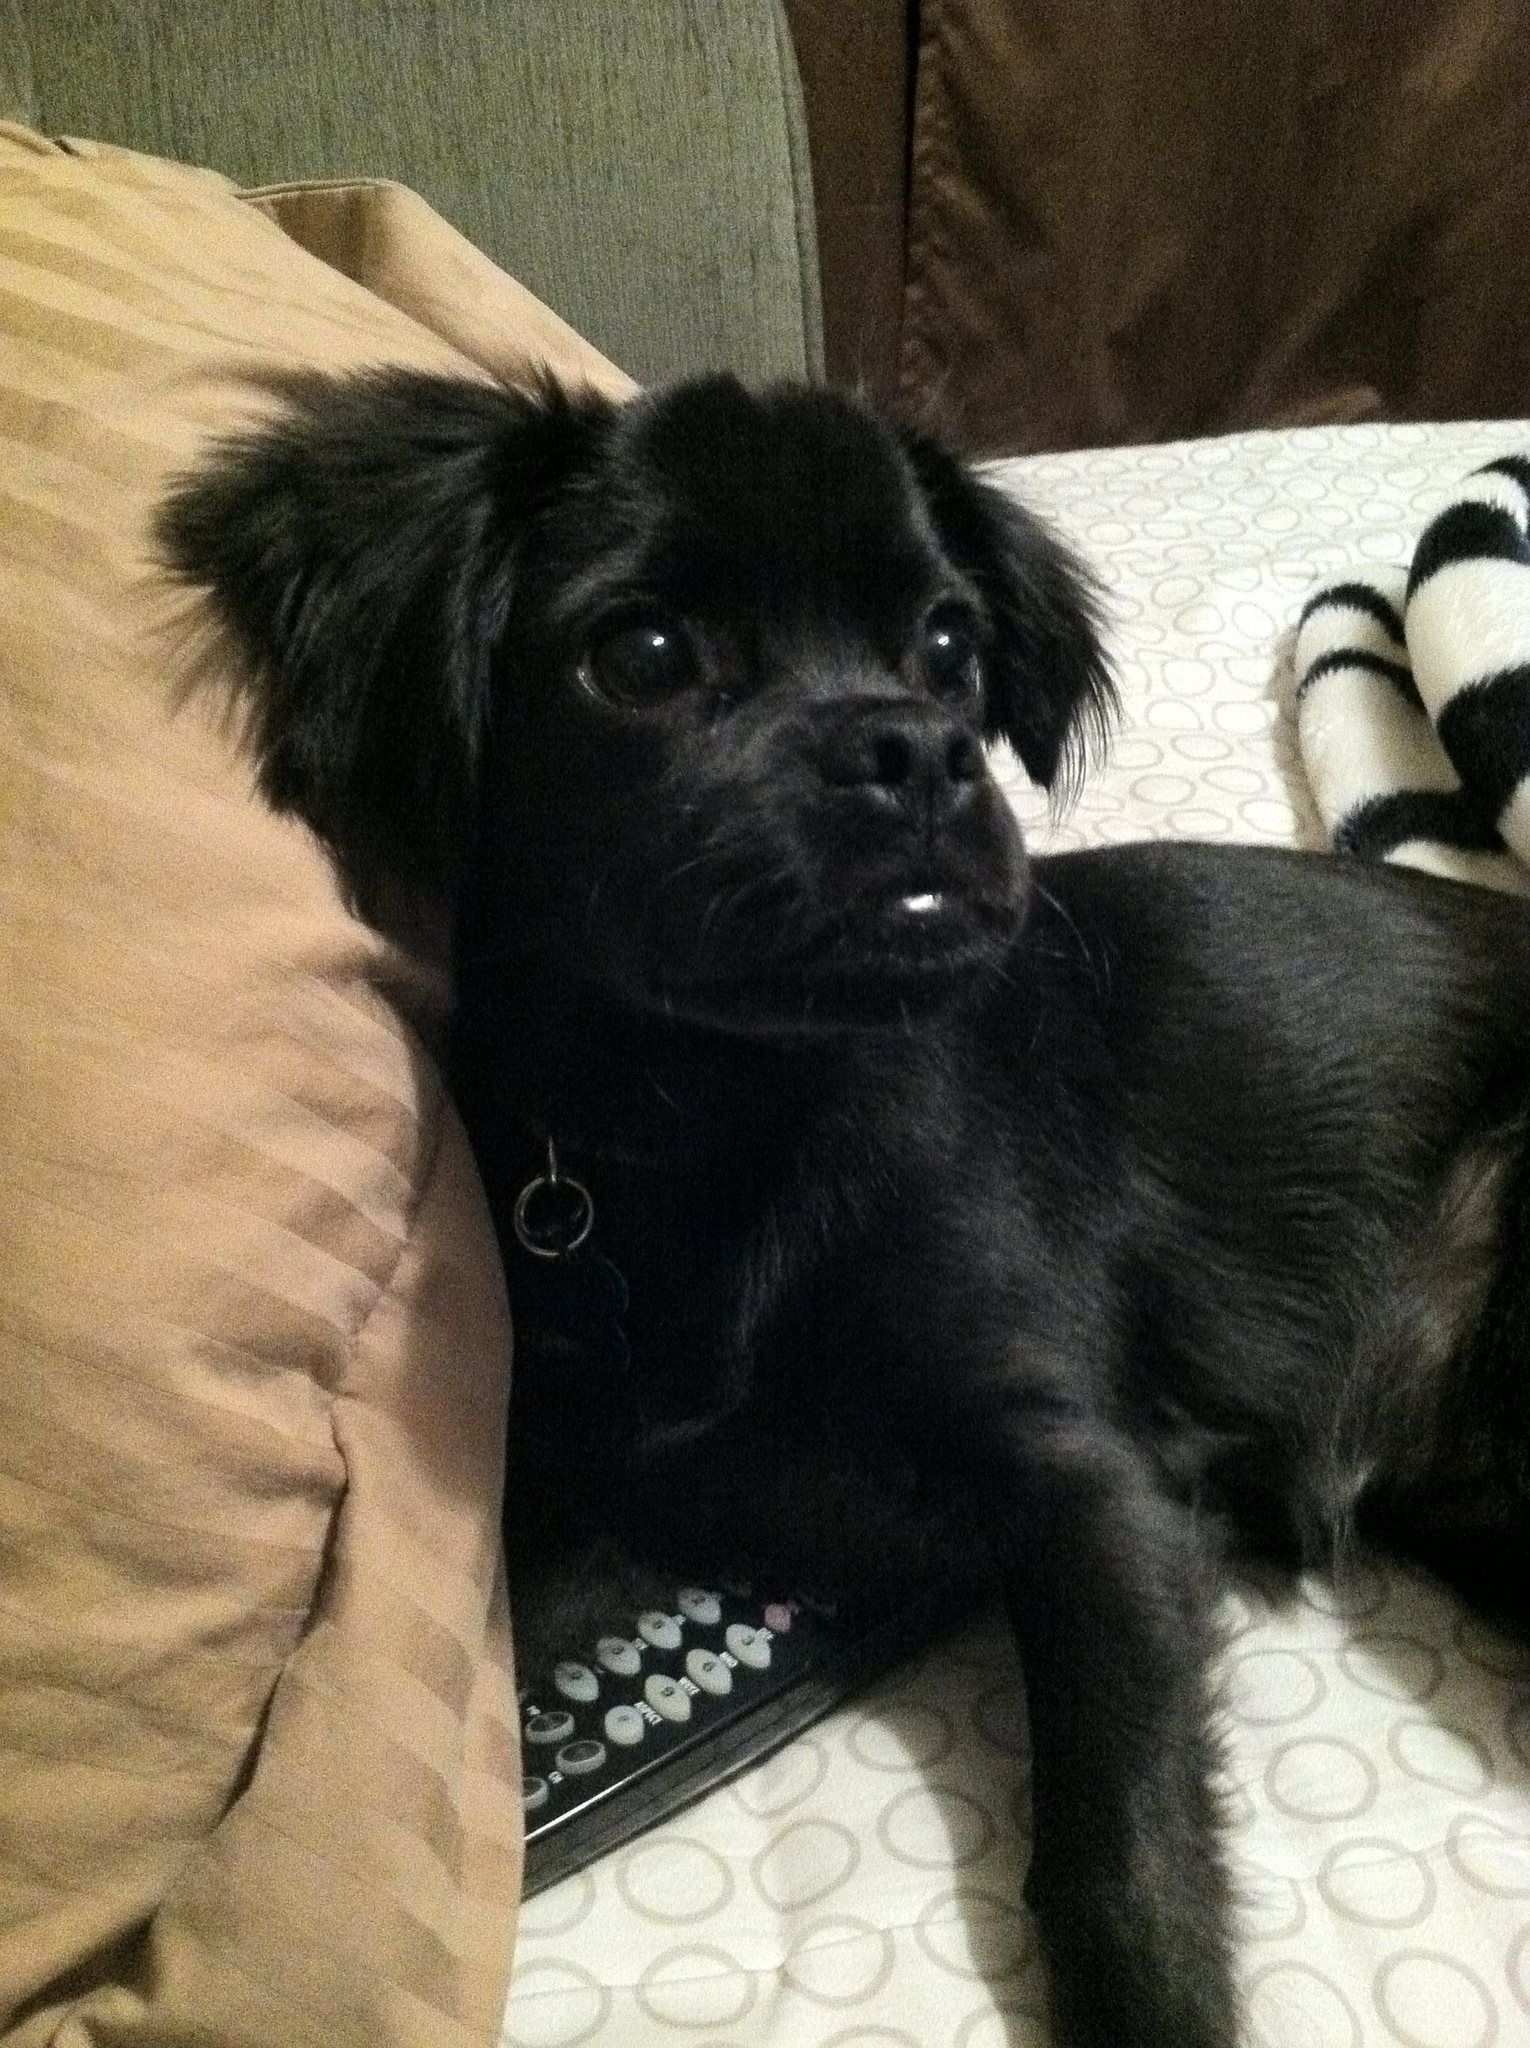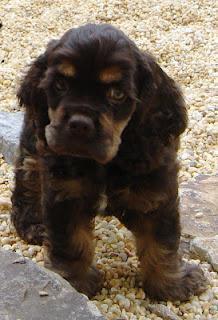The first image is the image on the left, the second image is the image on the right. For the images displayed, is the sentence "One dark puppy is standing, and the other dark puppy is reclining." factually correct? Answer yes or no. Yes. The first image is the image on the left, the second image is the image on the right. Given the left and right images, does the statement "A single dog is posed on grass in the left image." hold true? Answer yes or no. No. 